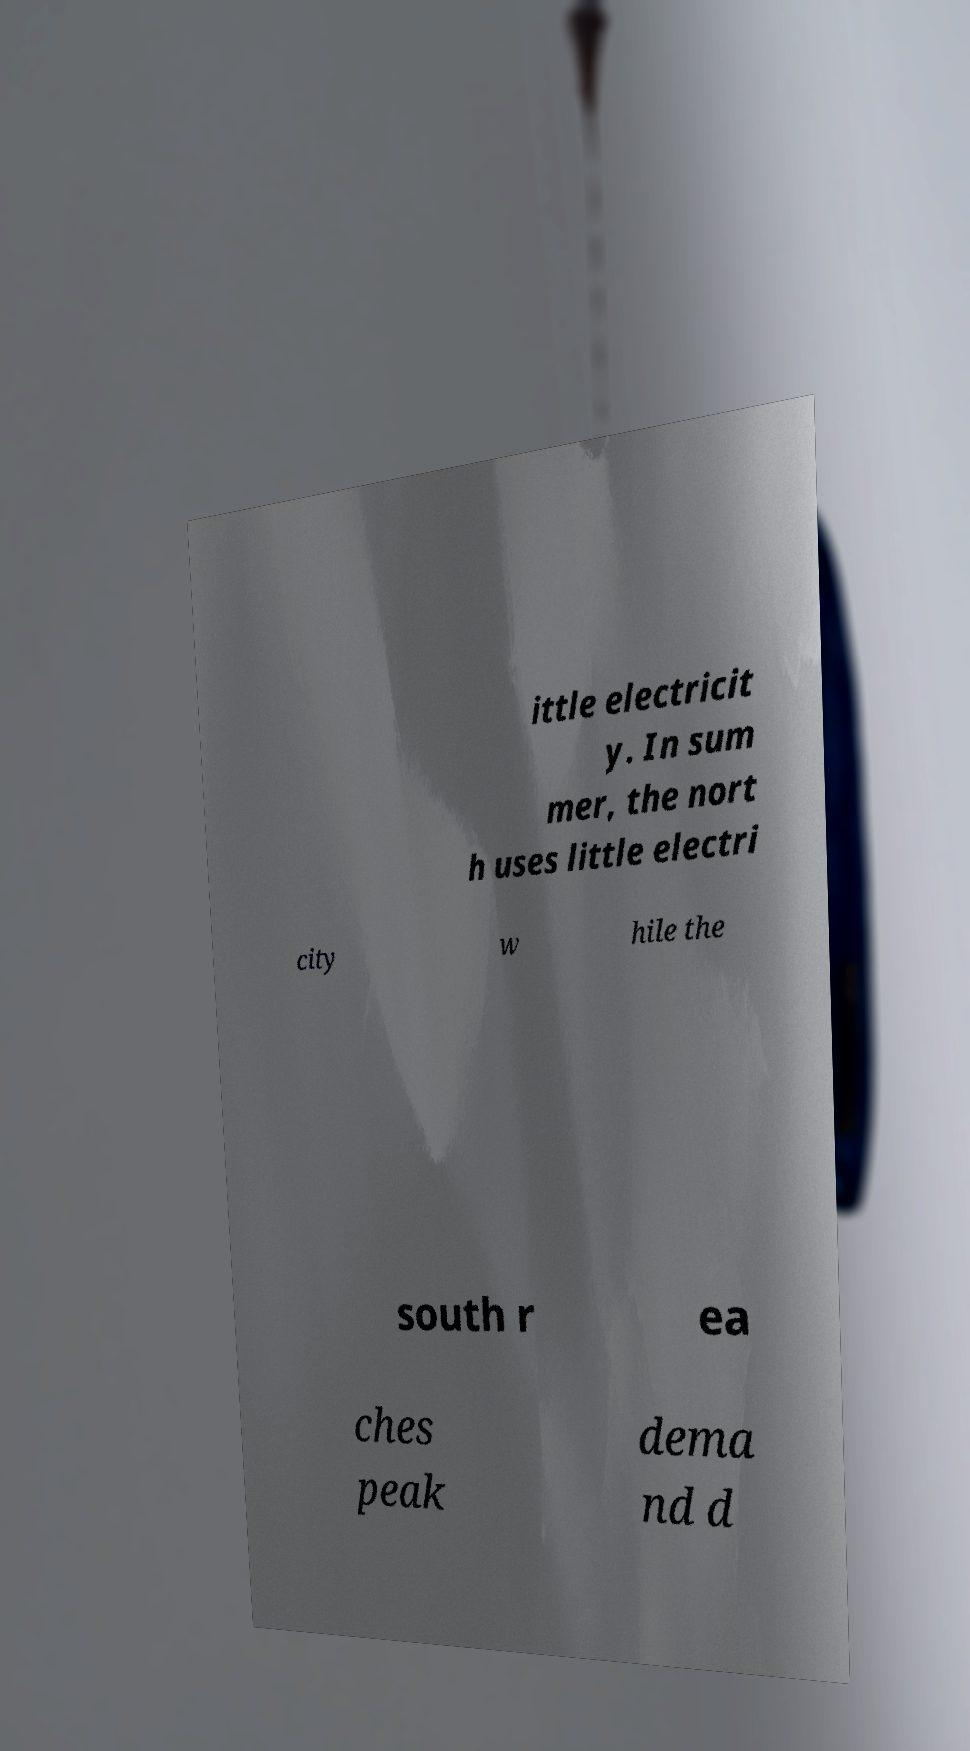Could you assist in decoding the text presented in this image and type it out clearly? ittle electricit y. In sum mer, the nort h uses little electri city w hile the south r ea ches peak dema nd d 